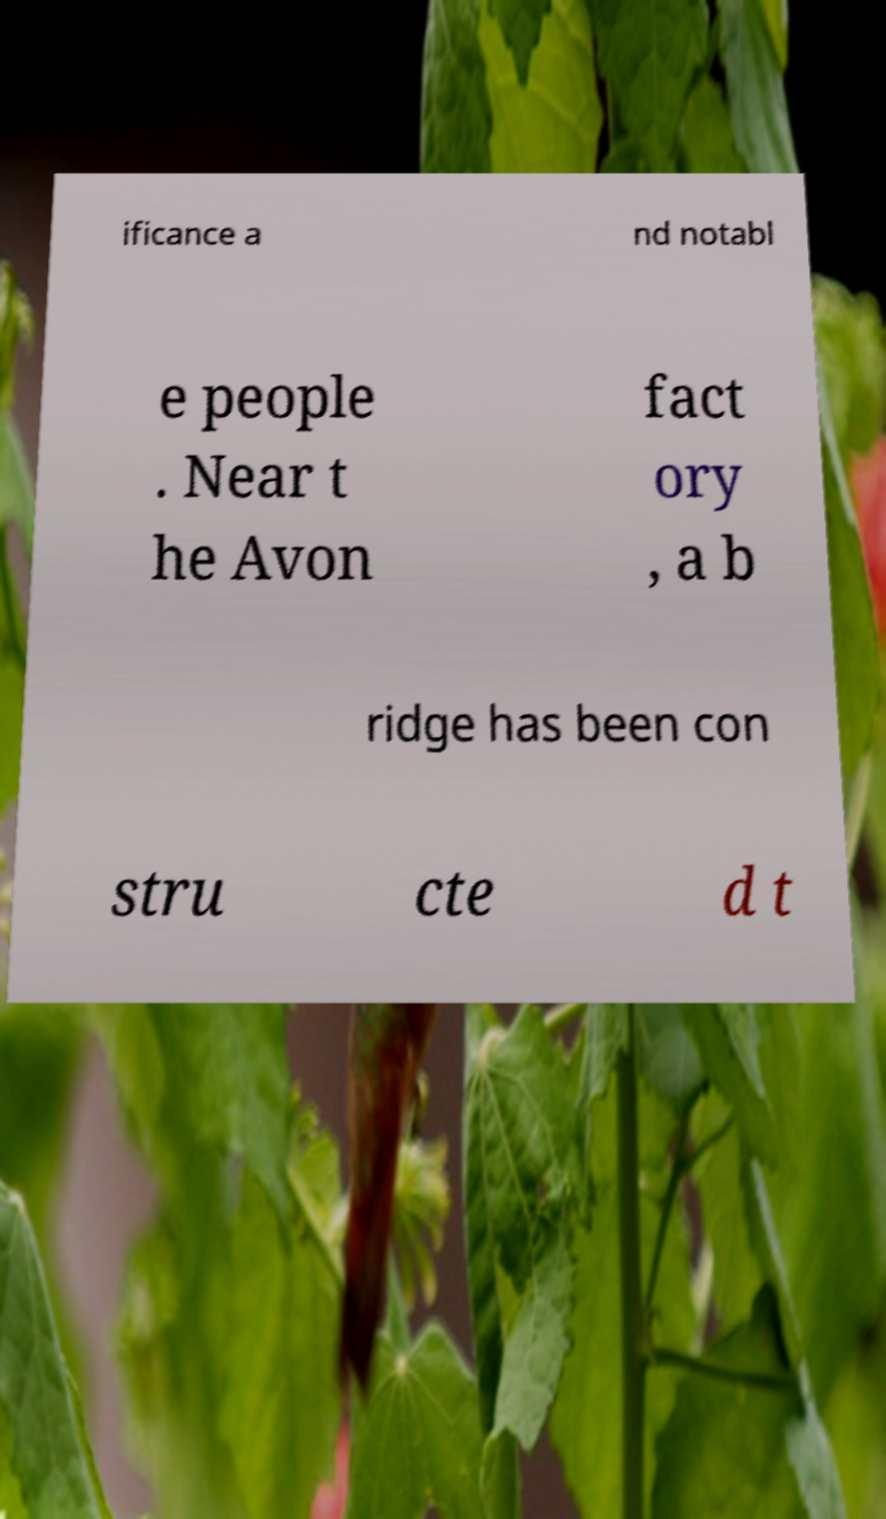I need the written content from this picture converted into text. Can you do that? ificance a nd notabl e people . Near t he Avon fact ory , a b ridge has been con stru cte d t 